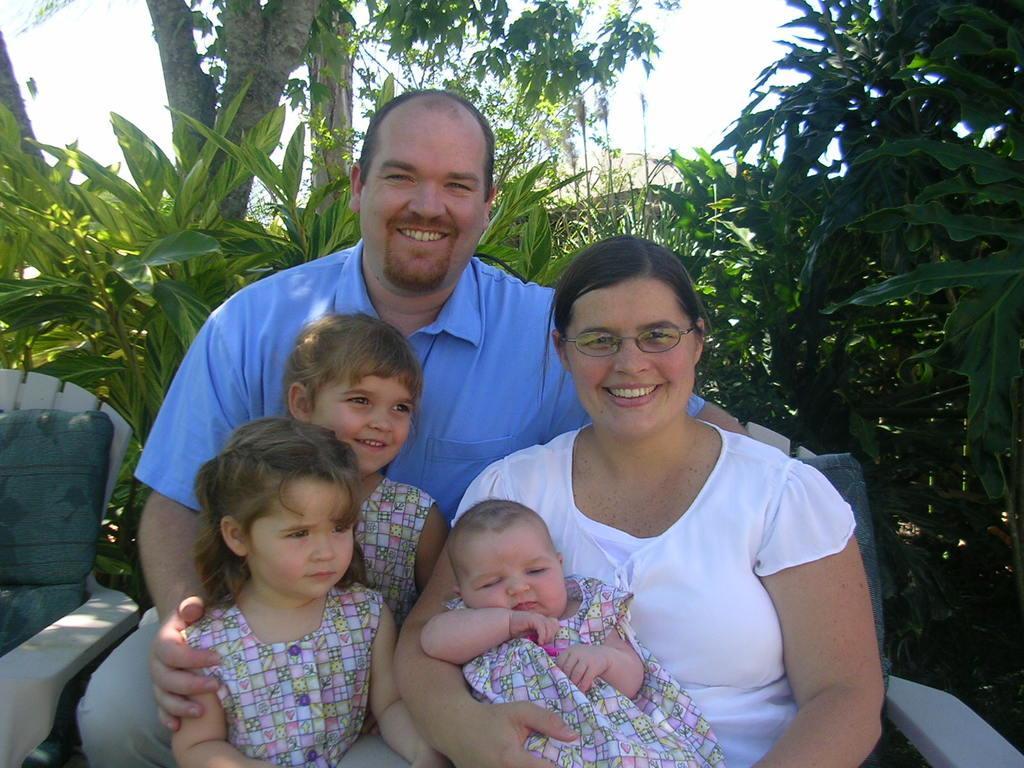In one or two sentences, can you explain what this image depicts? In this picture, we can see a few people sitting on a chair and we can see a chair in the right corner and we can see some trees and the sky. 